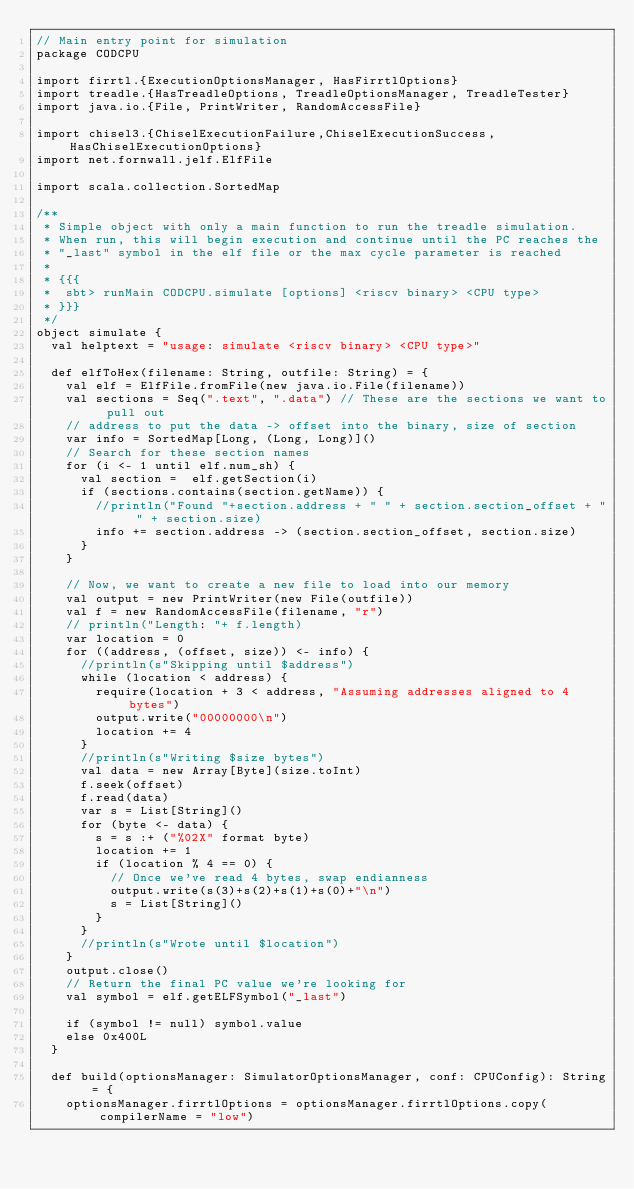<code> <loc_0><loc_0><loc_500><loc_500><_Scala_>// Main entry point for simulation
package CODCPU

import firrtl.{ExecutionOptionsManager, HasFirrtlOptions}
import treadle.{HasTreadleOptions, TreadleOptionsManager, TreadleTester}
import java.io.{File, PrintWriter, RandomAccessFile}

import chisel3.{ChiselExecutionFailure,ChiselExecutionSuccess,HasChiselExecutionOptions}
import net.fornwall.jelf.ElfFile

import scala.collection.SortedMap

/**
 * Simple object with only a main function to run the treadle simulation.
 * When run, this will begin execution and continue until the PC reaches the
 * "_last" symbol in the elf file or the max cycle parameter is reached
 *
 * {{{
 *  sbt> runMain CODCPU.simulate [options] <riscv binary> <CPU type>
 * }}}
 */
object simulate {
  val helptext = "usage: simulate <riscv binary> <CPU type>"

  def elfToHex(filename: String, outfile: String) = {
    val elf = ElfFile.fromFile(new java.io.File(filename))
    val sections = Seq(".text", ".data") // These are the sections we want to pull out
    // address to put the data -> offset into the binary, size of section
    var info = SortedMap[Long, (Long, Long)]()
    // Search for these section names
    for (i <- 1 until elf.num_sh) {
      val section =  elf.getSection(i)
      if (sections.contains(section.getName)) {
        //println("Found "+section.address + " " + section.section_offset + " " + section.size)
        info += section.address -> (section.section_offset, section.size)
      }
    }

    // Now, we want to create a new file to load into our memory
    val output = new PrintWriter(new File(outfile))
    val f = new RandomAccessFile(filename, "r")
    // println("Length: "+ f.length)
    var location = 0
    for ((address, (offset, size)) <- info) {
      //println(s"Skipping until $address")
      while (location < address) {
        require(location + 3 < address, "Assuming addresses aligned to 4 bytes")
        output.write("00000000\n")
        location += 4
      }
      //println(s"Writing $size bytes")
      val data = new Array[Byte](size.toInt)
      f.seek(offset)
      f.read(data)
      var s = List[String]()
      for (byte <- data) {
        s = s :+ ("%02X" format byte)
        location += 1
        if (location % 4 == 0) {
          // Once we've read 4 bytes, swap endianness
          output.write(s(3)+s(2)+s(1)+s(0)+"\n")
          s = List[String]()
        }
      }
      //println(s"Wrote until $location")
    }
    output.close()
    // Return the final PC value we're looking for
    val symbol = elf.getELFSymbol("_last")

    if (symbol != null) symbol.value
    else 0x400L
  }

  def build(optionsManager: SimulatorOptionsManager, conf: CPUConfig): String = {
    optionsManager.firrtlOptions = optionsManager.firrtlOptions.copy(compilerName = "low")</code> 